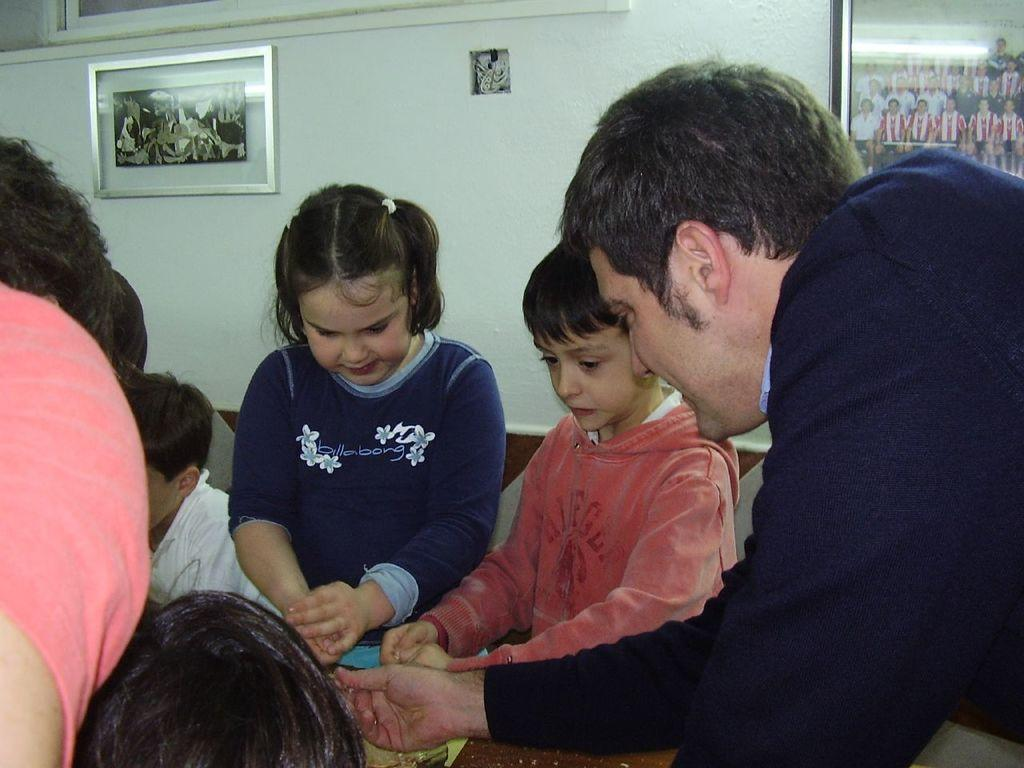Who or what can be seen in the image? There are people in the image. What can be seen on the wall in the background of the image? There are photo frames on a wall in the background of the image. What type of veil can be seen covering the photo frames in the image? There is no veil present in the image; the photo frames are visible without any covering. 